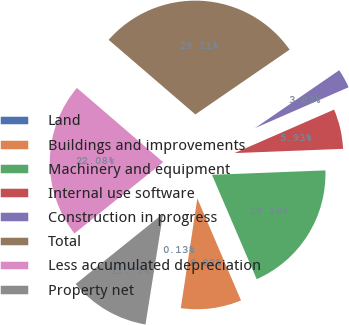Convert chart to OTSL. <chart><loc_0><loc_0><loc_500><loc_500><pie_chart><fcel>Land<fcel>Buildings and improvements<fcel>Machinery and equipment<fcel>Internal use software<fcel>Construction in progress<fcel>Total<fcel>Less accumulated depreciation<fcel>Property net<nl><fcel>0.13%<fcel>8.82%<fcel>19.18%<fcel>5.93%<fcel>3.03%<fcel>29.11%<fcel>22.08%<fcel>11.72%<nl></chart> 